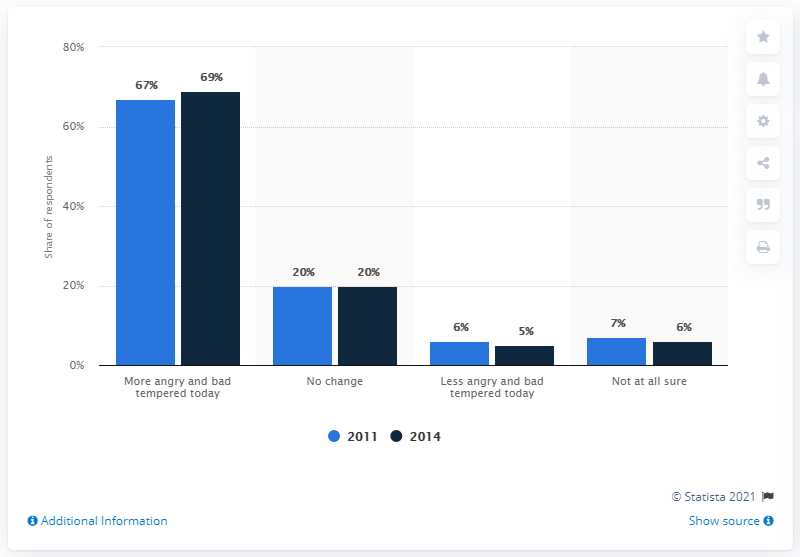Mention a couple of crucial points in this snapshot. The political climate was perceived to be angrier in 2014 than it was in 2011 by a significant proportion of people. The difference between the people who believed that the political climate was less angry from 2011 to 2014 was 1. 